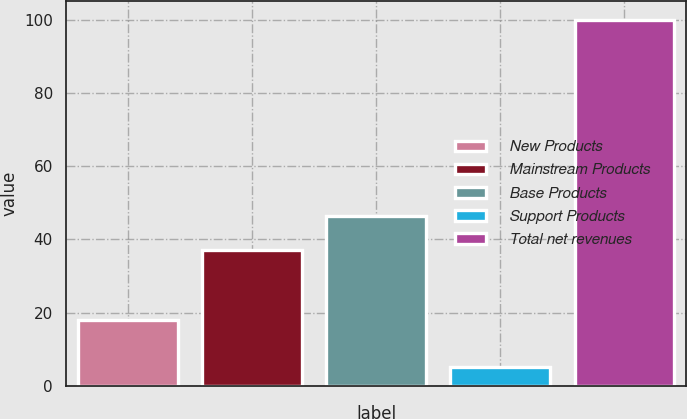<chart> <loc_0><loc_0><loc_500><loc_500><bar_chart><fcel>New Products<fcel>Mainstream Products<fcel>Base Products<fcel>Support Products<fcel>Total net revenues<nl><fcel>18<fcel>37<fcel>46.5<fcel>5<fcel>100<nl></chart> 